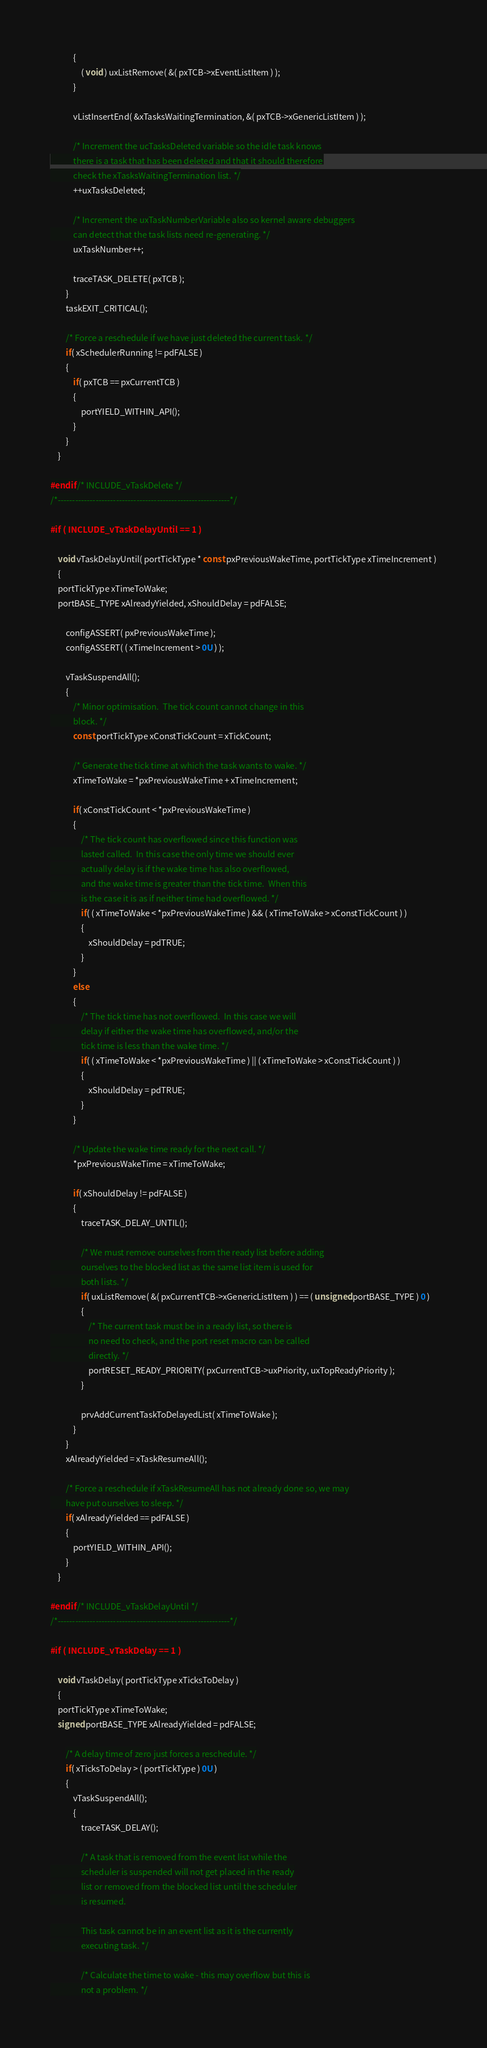<code> <loc_0><loc_0><loc_500><loc_500><_C_>			{
				( void ) uxListRemove( &( pxTCB->xEventListItem ) );
			}

			vListInsertEnd( &xTasksWaitingTermination, &( pxTCB->xGenericListItem ) );

			/* Increment the ucTasksDeleted variable so the idle task knows
			there is a task that has been deleted and that it should therefore
			check the xTasksWaitingTermination list. */
			++uxTasksDeleted;

			/* Increment the uxTaskNumberVariable also so kernel aware debuggers
			can detect that the task lists need re-generating. */
			uxTaskNumber++;

			traceTASK_DELETE( pxTCB );
		}
		taskEXIT_CRITICAL();

		/* Force a reschedule if we have just deleted the current task. */
		if( xSchedulerRunning != pdFALSE )
		{
			if( pxTCB == pxCurrentTCB )
			{
				portYIELD_WITHIN_API();
			}
		}
	}

#endif /* INCLUDE_vTaskDelete */
/*-----------------------------------------------------------*/

#if ( INCLUDE_vTaskDelayUntil == 1 )

	void vTaskDelayUntil( portTickType * const pxPreviousWakeTime, portTickType xTimeIncrement )
	{
	portTickType xTimeToWake;
	portBASE_TYPE xAlreadyYielded, xShouldDelay = pdFALSE;

		configASSERT( pxPreviousWakeTime );
		configASSERT( ( xTimeIncrement > 0U ) );

		vTaskSuspendAll();
		{
			/* Minor optimisation.  The tick count cannot change in this
			block. */
			const portTickType xConstTickCount = xTickCount;

			/* Generate the tick time at which the task wants to wake. */
			xTimeToWake = *pxPreviousWakeTime + xTimeIncrement;

			if( xConstTickCount < *pxPreviousWakeTime )
			{
				/* The tick count has overflowed since this function was
				lasted called.  In this case the only time we should ever
				actually delay is if the wake time has also	overflowed,
				and the wake time is greater than the tick time.  When this
				is the case it is as if neither time had overflowed. */
				if( ( xTimeToWake < *pxPreviousWakeTime ) && ( xTimeToWake > xConstTickCount ) )
				{
					xShouldDelay = pdTRUE;
				}
			}
			else
			{
				/* The tick time has not overflowed.  In this case we will
				delay if either the wake time has overflowed, and/or the
				tick time is less than the wake time. */
				if( ( xTimeToWake < *pxPreviousWakeTime ) || ( xTimeToWake > xConstTickCount ) )
				{
					xShouldDelay = pdTRUE;
				}
			}

			/* Update the wake time ready for the next call. */
			*pxPreviousWakeTime = xTimeToWake;

			if( xShouldDelay != pdFALSE )
			{
				traceTASK_DELAY_UNTIL();

				/* We must remove ourselves from the ready list before adding
				ourselves to the blocked list as the same list item is used for
				both lists. */
				if( uxListRemove( &( pxCurrentTCB->xGenericListItem ) ) == ( unsigned portBASE_TYPE ) 0 )
				{
					/* The current task must be in a ready list, so there is
					no need to check, and the port reset macro can be called
					directly. */
					portRESET_READY_PRIORITY( pxCurrentTCB->uxPriority, uxTopReadyPriority );
				}

				prvAddCurrentTaskToDelayedList( xTimeToWake );
			}
		}
		xAlreadyYielded = xTaskResumeAll();

		/* Force a reschedule if xTaskResumeAll has not already done so, we may
		have put ourselves to sleep. */
		if( xAlreadyYielded == pdFALSE )
		{
			portYIELD_WITHIN_API();
		}
	}

#endif /* INCLUDE_vTaskDelayUntil */
/*-----------------------------------------------------------*/

#if ( INCLUDE_vTaskDelay == 1 )

	void vTaskDelay( portTickType xTicksToDelay )
	{
	portTickType xTimeToWake;
	signed portBASE_TYPE xAlreadyYielded = pdFALSE;

		/* A delay time of zero just forces a reschedule. */
		if( xTicksToDelay > ( portTickType ) 0U )
		{
			vTaskSuspendAll();
			{
				traceTASK_DELAY();

				/* A task that is removed from the event list while the
				scheduler is suspended will not get placed in the ready
				list or removed from the blocked list until the scheduler
				is resumed.

				This task cannot be in an event list as it is the currently
				executing task. */

				/* Calculate the time to wake - this may overflow but this is
				not a problem. */</code> 